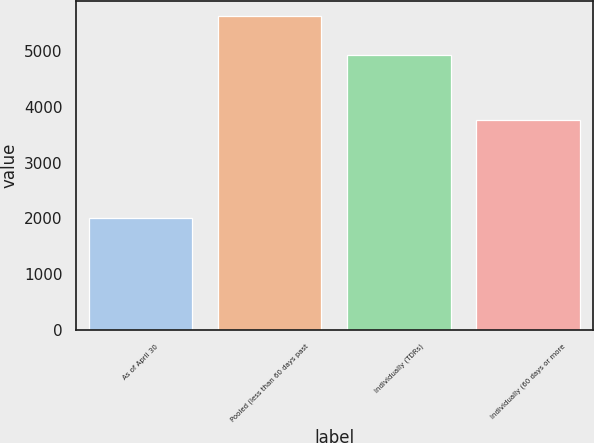Convert chart to OTSL. <chart><loc_0><loc_0><loc_500><loc_500><bar_chart><fcel>As of April 30<fcel>Pooled (less than 60 days past<fcel>Individually (TDRs)<fcel>Individually (60 days or more<nl><fcel>2013<fcel>5628<fcel>4924<fcel>3762<nl></chart> 